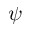<formula> <loc_0><loc_0><loc_500><loc_500>\psi</formula> 